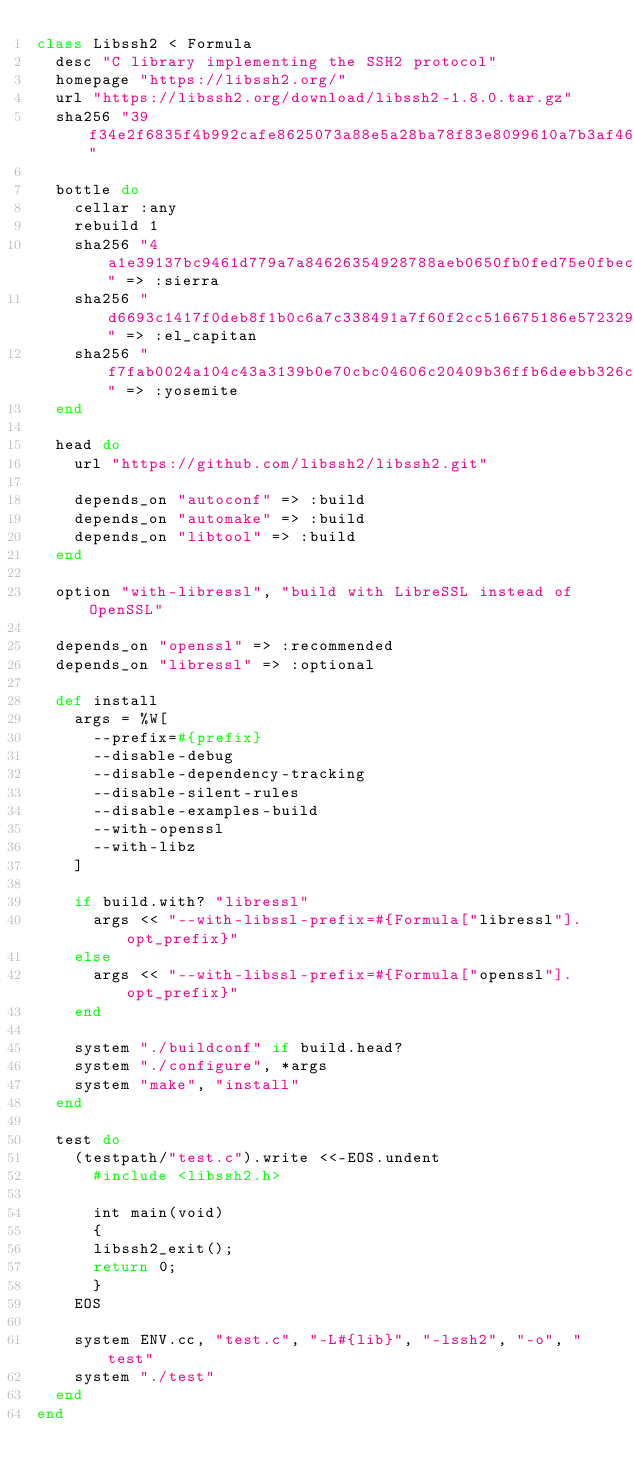Convert code to text. <code><loc_0><loc_0><loc_500><loc_500><_Ruby_>class Libssh2 < Formula
  desc "C library implementing the SSH2 protocol"
  homepage "https://libssh2.org/"
  url "https://libssh2.org/download/libssh2-1.8.0.tar.gz"
  sha256 "39f34e2f6835f4b992cafe8625073a88e5a28ba78f83e8099610a7b3af4676d4"

  bottle do
    cellar :any
    rebuild 1
    sha256 "4a1e39137bc9461d779a7a84626354928788aeb0650fb0fed75e0fbecb95c0cd" => :sierra
    sha256 "d6693c1417f0deb8f1b0c6a7c338491a7f60f2cc516675186e572329c1fcaa6c" => :el_capitan
    sha256 "f7fab0024a104c43a3139b0e70cbc04606c20409b36ffb6deebb326c168c4547" => :yosemite
  end

  head do
    url "https://github.com/libssh2/libssh2.git"

    depends_on "autoconf" => :build
    depends_on "automake" => :build
    depends_on "libtool" => :build
  end

  option "with-libressl", "build with LibreSSL instead of OpenSSL"

  depends_on "openssl" => :recommended
  depends_on "libressl" => :optional

  def install
    args = %W[
      --prefix=#{prefix}
      --disable-debug
      --disable-dependency-tracking
      --disable-silent-rules
      --disable-examples-build
      --with-openssl
      --with-libz
    ]

    if build.with? "libressl"
      args << "--with-libssl-prefix=#{Formula["libressl"].opt_prefix}"
    else
      args << "--with-libssl-prefix=#{Formula["openssl"].opt_prefix}"
    end

    system "./buildconf" if build.head?
    system "./configure", *args
    system "make", "install"
  end

  test do
    (testpath/"test.c").write <<-EOS.undent
      #include <libssh2.h>

      int main(void)
      {
      libssh2_exit();
      return 0;
      }
    EOS

    system ENV.cc, "test.c", "-L#{lib}", "-lssh2", "-o", "test"
    system "./test"
  end
end
</code> 